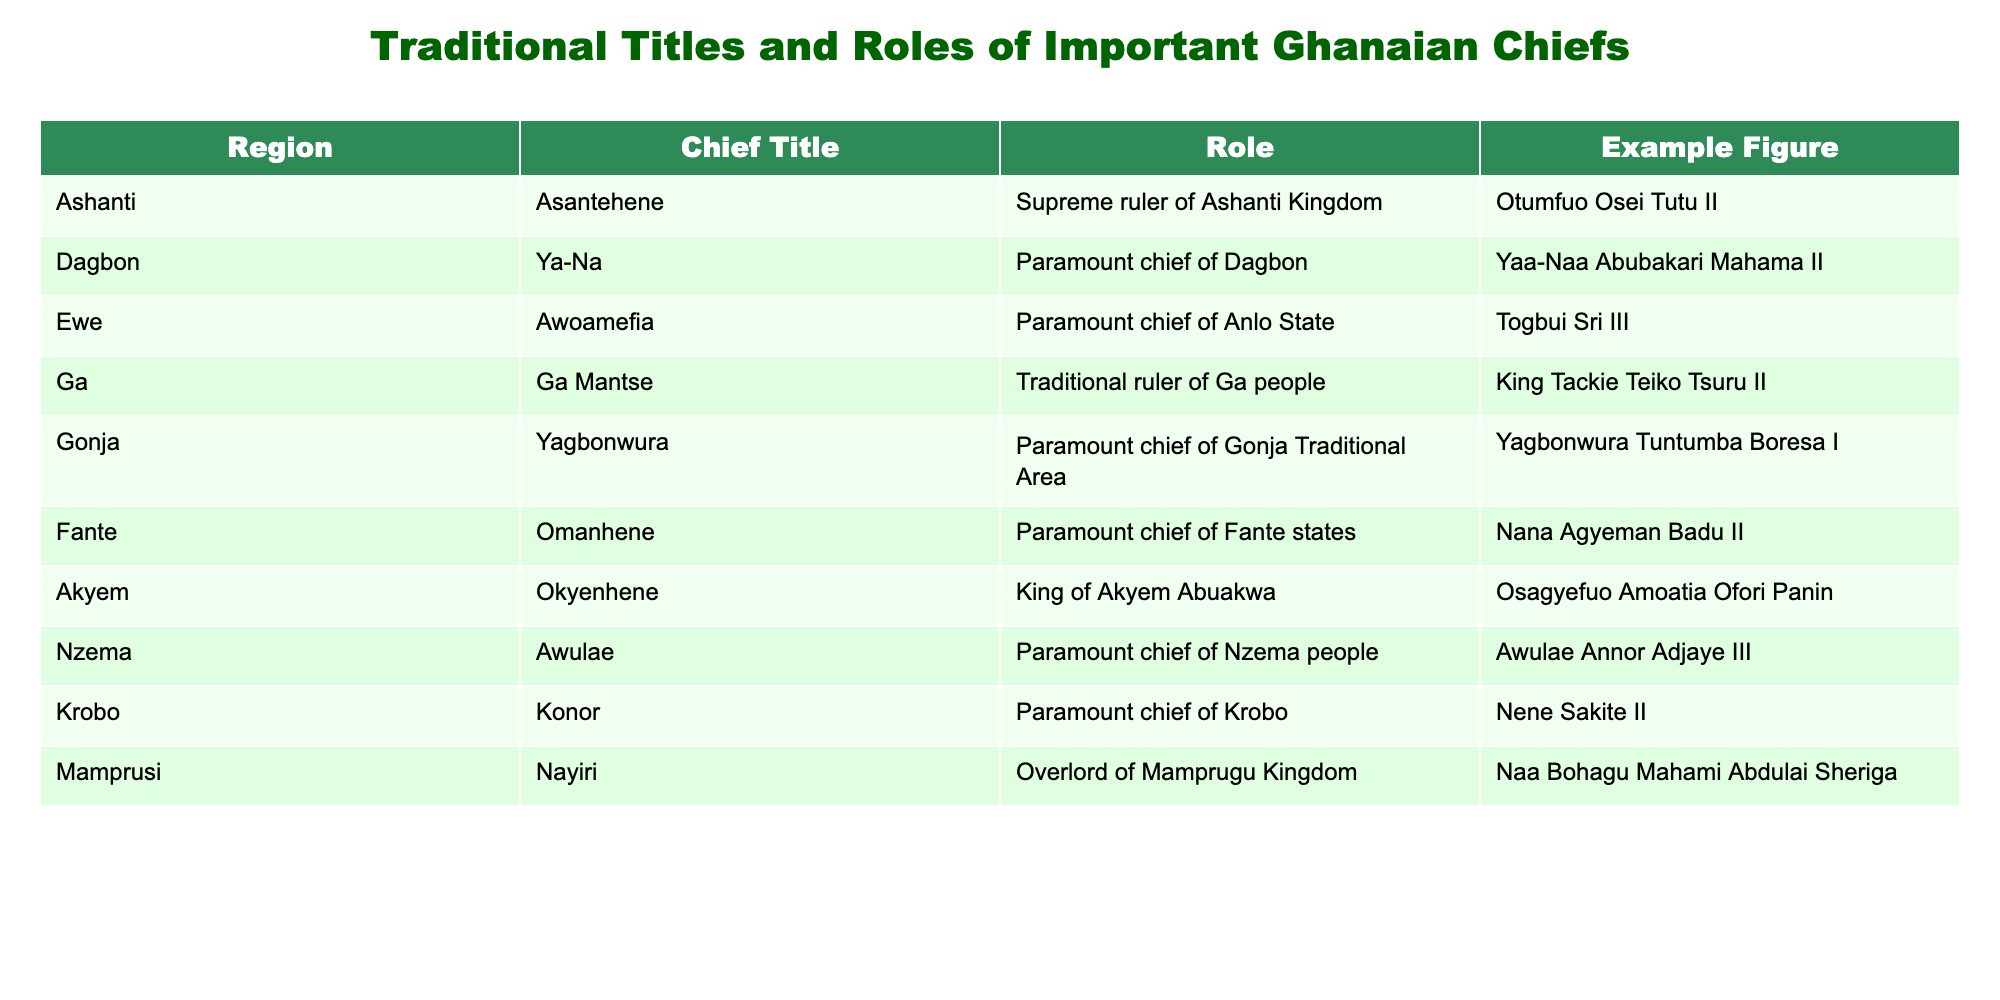What is the title of the chief from the Ashanti region? The Ashanti region is represented by the chief title "Asantehene." This information is directly retrieved from the table under the 'Region' and 'Chief Title' columns.
Answer: Asantehene Who is the paramount chief of the Dagbon region? The table lists "Ya-Na" as the chief title for the Dagbon region, and the example figure given is "Yaa-Naa Abubakari Mahama II." This shows the specific chief associated with the Dagbon area.
Answer: Yaa-Naa Abubakari Mahama II List the chief titles from the table. The chief titles in the table include Asantehene, Ya-Na, Awoamefia, Ga Mantse, Yagbonwura, Omanhene, Okyenhene, Awulae, Konor, and Nayiri. Compiling the unique titles from the 'Chief Title' column yields this list.
Answer: Asantehene, Ya-Na, Awoamefia, Ga Mantse, Yagbonwura, Omanhene, Okyenhene, Awulae, Konor, Nayiri Is the Ga Mantse a paramount chief? According to the table, the title "Ga Mantse" is described as the traditional ruler of the Ga people, which implies a significant but not necessarily a paramount role. This means the fact is true under the defined criteria.
Answer: No How many regions have chiefs referred to as "paramount chiefs"? In the table, the titles "Ya-Na" (Dagbon), "Awoamefia" (Ewe), "Yagbonwura" (Gonja), "Omanhene" (Fante), "Awulae" (Nzema), and "Konor" (Krobo) all classify as "paramount chiefs." There are six regions fulfilling this criterion specified in the 'Role' column.
Answer: 6 Which chief title corresponds with the example figure "Nene Sakite II"? The example figure "Nene Sakite II" is linked to the chief title "Konor," as recorded in the table under the appropriate region. This lets us identify the title accurately.
Answer: Konor What role does the Okyenhene perform? According to the table, the Okyenhene is defined as the King of Akyem Abuakwa. This is explicitly stated under the 'Role' section of the table.
Answer: King of Akyem Abuakwa How does the role of the Yagbonwura compare to that of the Omanhene? The Yagbonwura is the paramount chief of the Gonja Traditional Area, while the Omanhene is the paramount chief of the Fante states. Both serve as paramount chiefs in different regions, which establishes equivalence in their roles within their traditional societies.
Answer: Both are paramount chiefs What is the unique title for the chief of the Nzema people and who holds it? The unique title for the chief of the Nzema people is "Awulae," and it is held by "Awulae Annor Adjaye III," as recorded in the table. This is a direct retrieval of facts under the specified columns.
Answer: Awulae; Awulae Annor Adjaye III Which regions have chiefs with the title of "Nayiri"? The Nayiri is specifically associated with the Mamprusi region in the table. Since "Nayiri" only appears once, it indicates a unique association with this particular region.
Answer: Mamprusi 